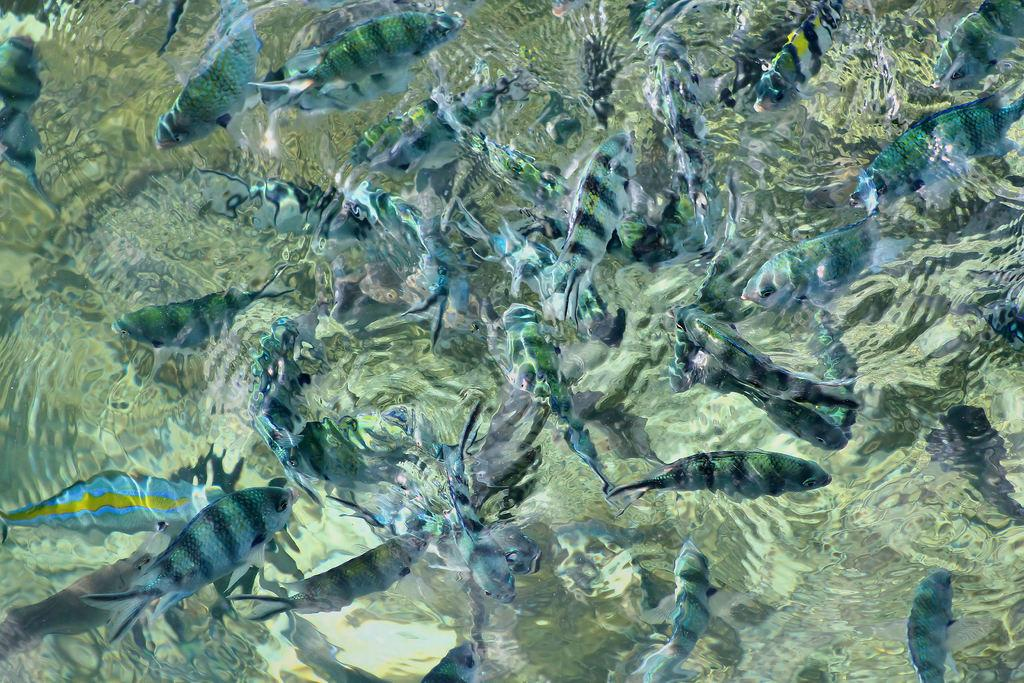What type of animals can be seen in the image? There are fishes in the image. Where are the fishes located? The fishes are in the water. What type of grass can be seen growing on the road in the image? There is no grass or road present in the image; it features fishes in the water. 